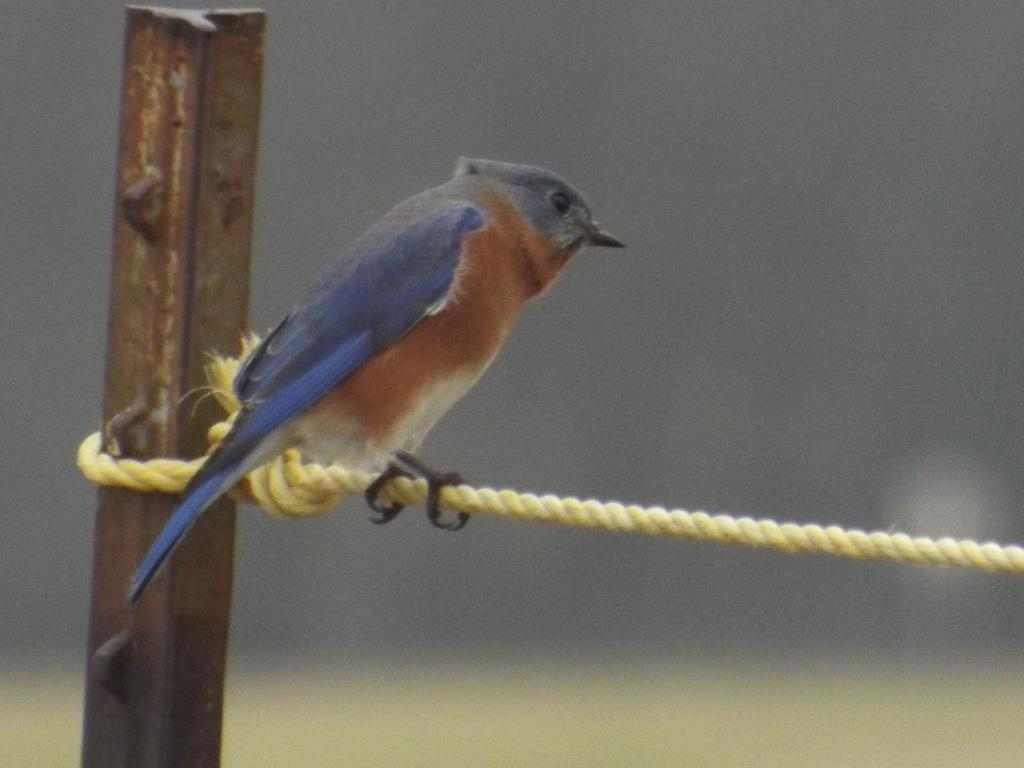What type of animal is present in the image? There is a bird in the image. Can you describe any other objects or elements in the background of the image? There is a blurry rod in the background of the image. Can you tell me how many patches are visible in the garden in the image? There is no garden or patches present in the image; it features a bird and a blurry rod in the background. 